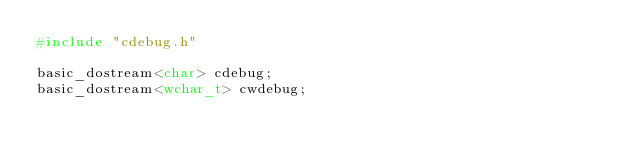<code> <loc_0><loc_0><loc_500><loc_500><_C++_>#include "cdebug.h"

basic_dostream<char> cdebug;
basic_dostream<wchar_t> cwdebug;
</code> 